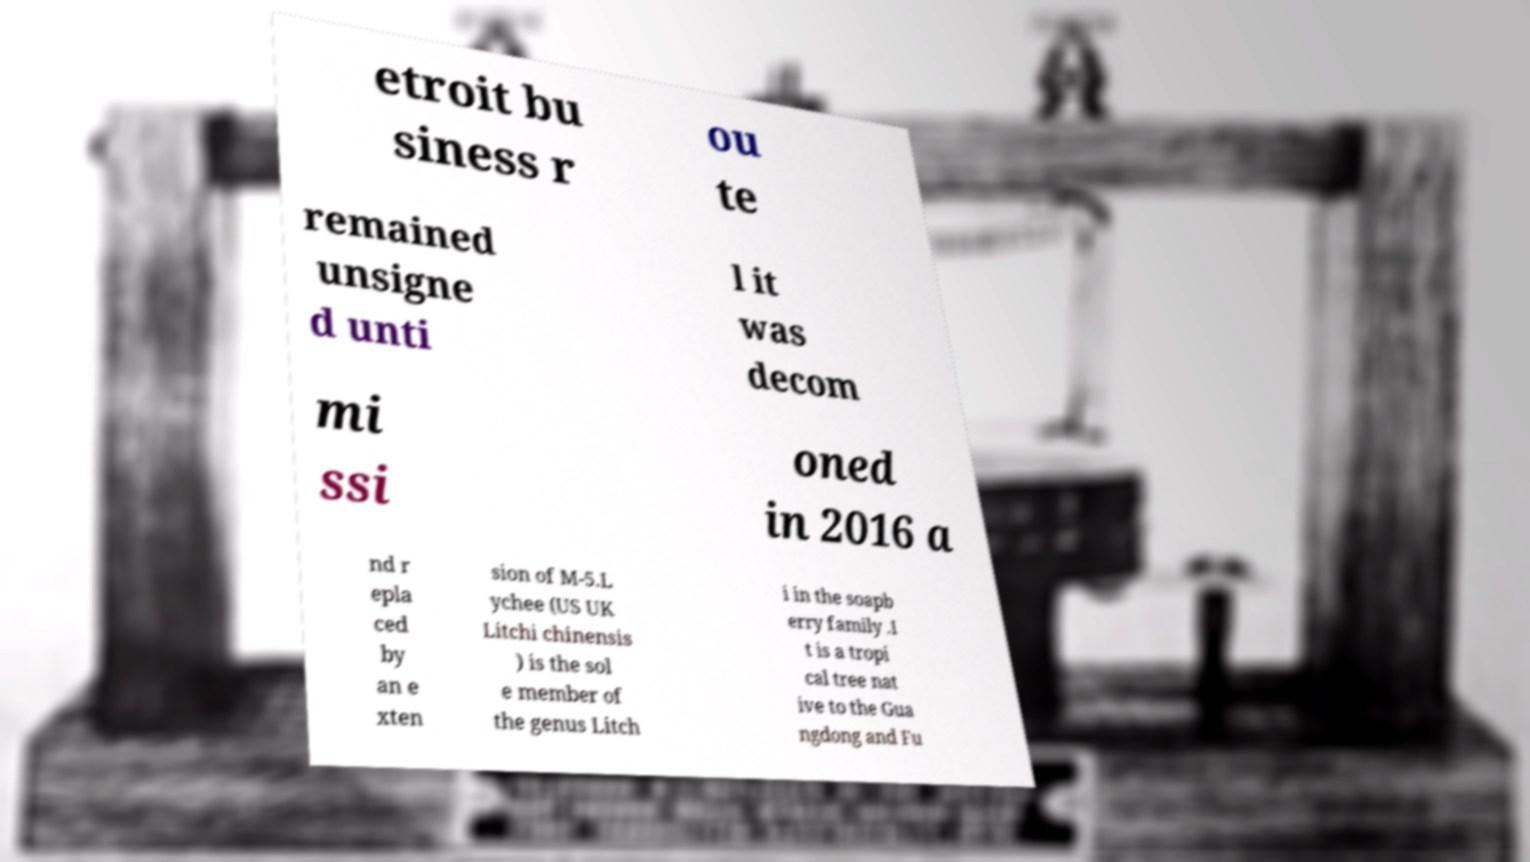What messages or text are displayed in this image? I need them in a readable, typed format. etroit bu siness r ou te remained unsigne d unti l it was decom mi ssi oned in 2016 a nd r epla ced by an e xten sion of M-5.L ychee (US UK Litchi chinensis ) is the sol e member of the genus Litch i in the soapb erry family .I t is a tropi cal tree nat ive to the Gua ngdong and Fu 